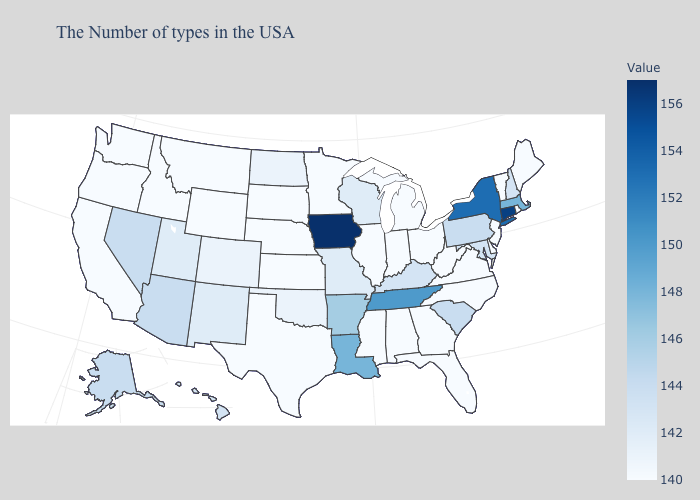Does Iowa have the highest value in the USA?
Keep it brief. Yes. Does Iowa have the highest value in the USA?
Concise answer only. Yes. Does Iowa have the highest value in the USA?
Quick response, please. Yes. Among the states that border Washington , which have the lowest value?
Concise answer only. Idaho, Oregon. Which states have the lowest value in the MidWest?
Answer briefly. Ohio, Michigan, Indiana, Illinois, Minnesota, Kansas, Nebraska, South Dakota. Is the legend a continuous bar?
Be succinct. Yes. 